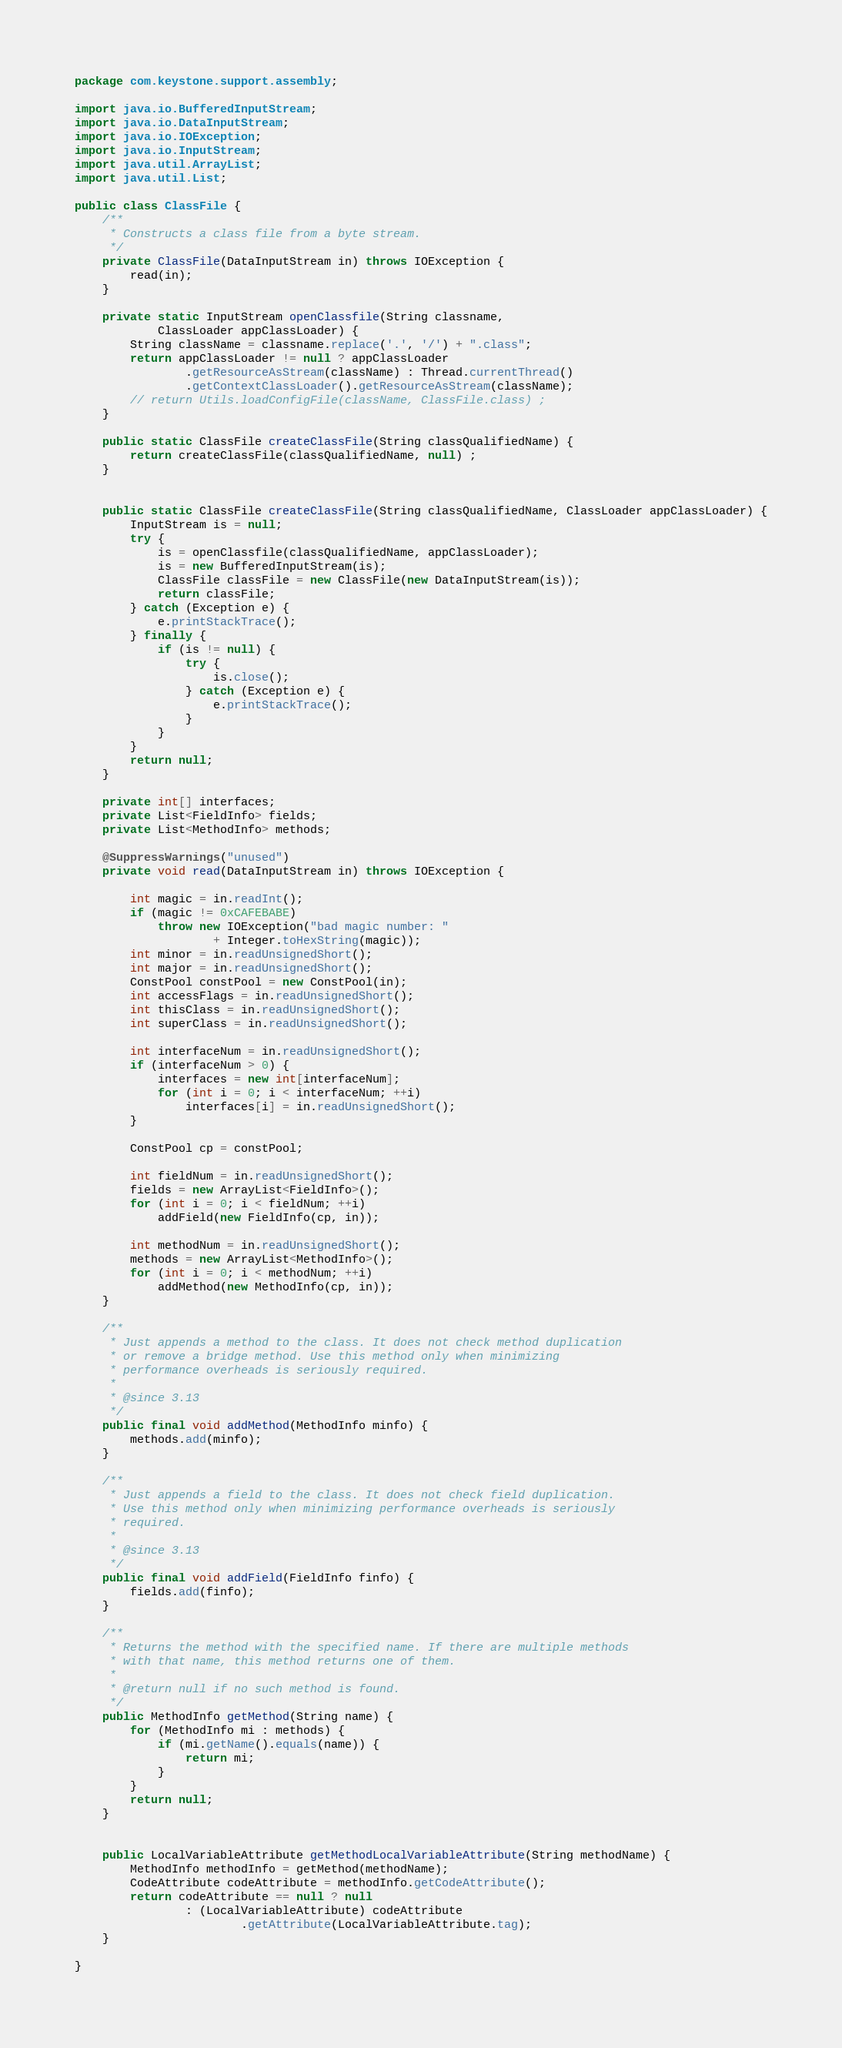Convert code to text. <code><loc_0><loc_0><loc_500><loc_500><_Java_>package com.keystone.support.assembly;

import java.io.BufferedInputStream;
import java.io.DataInputStream;
import java.io.IOException;
import java.io.InputStream;
import java.util.ArrayList;
import java.util.List;

public class ClassFile {
	/**
	 * Constructs a class file from a byte stream.
	 */
	private ClassFile(DataInputStream in) throws IOException {
		read(in);
	}

	private static InputStream openClassfile(String classname,
			ClassLoader appClassLoader) {
		String className = classname.replace('.', '/') + ".class";
		return appClassLoader != null ? appClassLoader
				.getResourceAsStream(className) : Thread.currentThread()
				.getContextClassLoader().getResourceAsStream(className);
		// return Utils.loadConfigFile(className, ClassFile.class) ;
	}

	public static ClassFile createClassFile(String classQualifiedName) {
		return createClassFile(classQualifiedName, null) ;
	}
	
	
	public static ClassFile createClassFile(String classQualifiedName, ClassLoader appClassLoader) {
		InputStream is = null;
		try {
			is = openClassfile(classQualifiedName, appClassLoader);
			is = new BufferedInputStream(is);
			ClassFile classFile = new ClassFile(new DataInputStream(is));
			return classFile;
		} catch (Exception e) {
			e.printStackTrace();
		} finally {
			if (is != null) {
				try {
					is.close();
				} catch (Exception e) {
					e.printStackTrace();
				}
			}
		}
		return null;
	}

	private int[] interfaces;
	private List<FieldInfo> fields;
	private List<MethodInfo> methods;

	@SuppressWarnings("unused")
	private void read(DataInputStream in) throws IOException {

		int magic = in.readInt();
		if (magic != 0xCAFEBABE)
			throw new IOException("bad magic number: "
					+ Integer.toHexString(magic));
		int minor = in.readUnsignedShort();
		int major = in.readUnsignedShort();
		ConstPool constPool = new ConstPool(in);
		int accessFlags = in.readUnsignedShort();
		int thisClass = in.readUnsignedShort();
		int superClass = in.readUnsignedShort();

		int interfaceNum = in.readUnsignedShort();
		if (interfaceNum > 0) {
			interfaces = new int[interfaceNum];
			for (int i = 0; i < interfaceNum; ++i)
				interfaces[i] = in.readUnsignedShort();
		}

		ConstPool cp = constPool;

		int fieldNum = in.readUnsignedShort();
		fields = new ArrayList<FieldInfo>();
		for (int i = 0; i < fieldNum; ++i)
			addField(new FieldInfo(cp, in));

		int methodNum = in.readUnsignedShort();
		methods = new ArrayList<MethodInfo>();
		for (int i = 0; i < methodNum; ++i)
			addMethod(new MethodInfo(cp, in));
	}

	/**
	 * Just appends a method to the class. It does not check method duplication
	 * or remove a bridge method. Use this method only when minimizing
	 * performance overheads is seriously required.
	 * 
	 * @since 3.13
	 */
	public final void addMethod(MethodInfo minfo) {
		methods.add(minfo);
	}

	/**
	 * Just appends a field to the class. It does not check field duplication.
	 * Use this method only when minimizing performance overheads is seriously
	 * required.
	 * 
	 * @since 3.13
	 */
	public final void addField(FieldInfo finfo) {
		fields.add(finfo);
	}

	/**
	 * Returns the method with the specified name. If there are multiple methods
	 * with that name, this method returns one of them.
	 * 
	 * @return null if no such method is found.
	 */
	public MethodInfo getMethod(String name) {
		for (MethodInfo mi : methods) {
			if (mi.getName().equals(name)) {
				return mi;
			}
		}
		return null;
	}
	
	
	public LocalVariableAttribute getMethodLocalVariableAttribute(String methodName) {
		MethodInfo methodInfo = getMethod(methodName);
		CodeAttribute codeAttribute = methodInfo.getCodeAttribute();
		return codeAttribute == null ? null
				: (LocalVariableAttribute) codeAttribute
						.getAttribute(LocalVariableAttribute.tag);
	}

}
</code> 